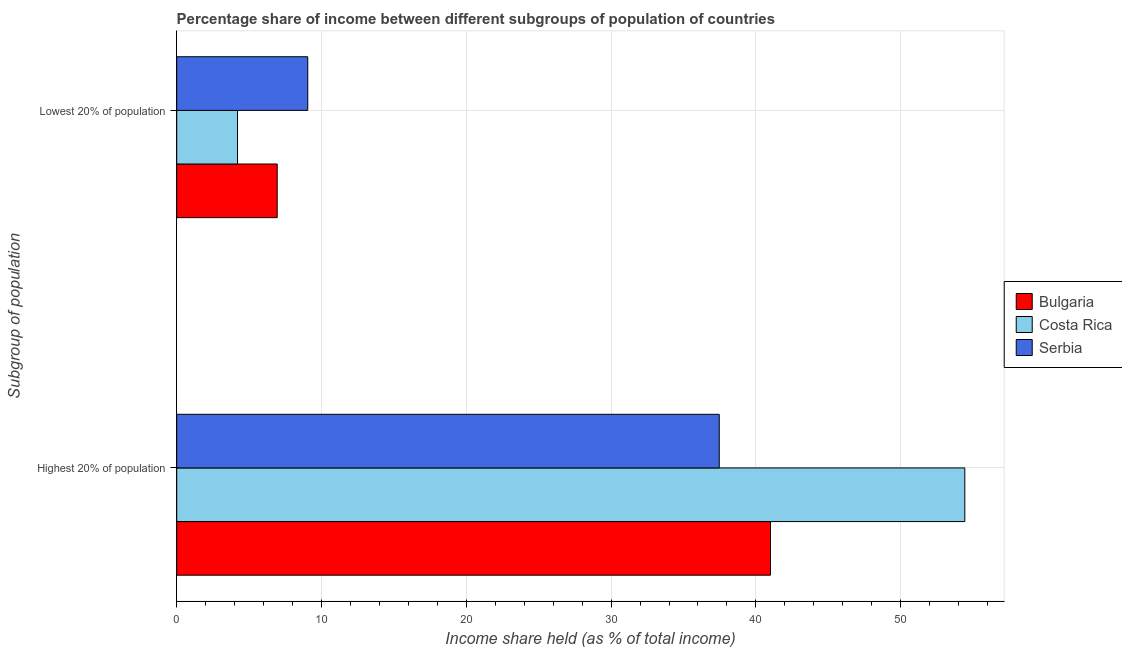Are the number of bars per tick equal to the number of legend labels?
Provide a succinct answer. Yes. How many bars are there on the 2nd tick from the top?
Ensure brevity in your answer.  3. What is the label of the 2nd group of bars from the top?
Offer a terse response. Highest 20% of population. What is the income share held by highest 20% of the population in Costa Rica?
Your answer should be very brief. 54.43. Across all countries, what is the maximum income share held by highest 20% of the population?
Offer a terse response. 54.43. In which country was the income share held by lowest 20% of the population maximum?
Make the answer very short. Serbia. In which country was the income share held by highest 20% of the population minimum?
Your answer should be very brief. Serbia. What is the total income share held by lowest 20% of the population in the graph?
Ensure brevity in your answer.  20.19. What is the difference between the income share held by highest 20% of the population in Serbia and that in Bulgaria?
Your answer should be very brief. -3.54. What is the difference between the income share held by highest 20% of the population in Bulgaria and the income share held by lowest 20% of the population in Costa Rica?
Provide a succinct answer. 36.81. What is the average income share held by lowest 20% of the population per country?
Your response must be concise. 6.73. What is the difference between the income share held by highest 20% of the population and income share held by lowest 20% of the population in Bulgaria?
Your response must be concise. 34.07. In how many countries, is the income share held by highest 20% of the population greater than 6 %?
Keep it short and to the point. 3. What is the ratio of the income share held by highest 20% of the population in Costa Rica to that in Bulgaria?
Make the answer very short. 1.33. Is the income share held by highest 20% of the population in Serbia less than that in Costa Rica?
Your answer should be compact. Yes. In how many countries, is the income share held by lowest 20% of the population greater than the average income share held by lowest 20% of the population taken over all countries?
Offer a terse response. 2. How many bars are there?
Give a very brief answer. 6. How many countries are there in the graph?
Ensure brevity in your answer.  3. Does the graph contain grids?
Make the answer very short. Yes. Where does the legend appear in the graph?
Make the answer very short. Center right. How are the legend labels stacked?
Your response must be concise. Vertical. What is the title of the graph?
Offer a terse response. Percentage share of income between different subgroups of population of countries. What is the label or title of the X-axis?
Make the answer very short. Income share held (as % of total income). What is the label or title of the Y-axis?
Your response must be concise. Subgroup of population. What is the Income share held (as % of total income) in Bulgaria in Highest 20% of population?
Keep it short and to the point. 41.01. What is the Income share held (as % of total income) of Costa Rica in Highest 20% of population?
Ensure brevity in your answer.  54.43. What is the Income share held (as % of total income) of Serbia in Highest 20% of population?
Provide a short and direct response. 37.47. What is the Income share held (as % of total income) in Bulgaria in Lowest 20% of population?
Offer a very short reply. 6.94. What is the Income share held (as % of total income) of Serbia in Lowest 20% of population?
Your answer should be compact. 9.05. Across all Subgroup of population, what is the maximum Income share held (as % of total income) in Bulgaria?
Your answer should be very brief. 41.01. Across all Subgroup of population, what is the maximum Income share held (as % of total income) in Costa Rica?
Your response must be concise. 54.43. Across all Subgroup of population, what is the maximum Income share held (as % of total income) of Serbia?
Your answer should be compact. 37.47. Across all Subgroup of population, what is the minimum Income share held (as % of total income) in Bulgaria?
Provide a succinct answer. 6.94. Across all Subgroup of population, what is the minimum Income share held (as % of total income) in Costa Rica?
Your answer should be compact. 4.2. Across all Subgroup of population, what is the minimum Income share held (as % of total income) in Serbia?
Your answer should be compact. 9.05. What is the total Income share held (as % of total income) of Bulgaria in the graph?
Give a very brief answer. 47.95. What is the total Income share held (as % of total income) of Costa Rica in the graph?
Your response must be concise. 58.63. What is the total Income share held (as % of total income) in Serbia in the graph?
Offer a terse response. 46.52. What is the difference between the Income share held (as % of total income) in Bulgaria in Highest 20% of population and that in Lowest 20% of population?
Ensure brevity in your answer.  34.07. What is the difference between the Income share held (as % of total income) in Costa Rica in Highest 20% of population and that in Lowest 20% of population?
Offer a terse response. 50.23. What is the difference between the Income share held (as % of total income) in Serbia in Highest 20% of population and that in Lowest 20% of population?
Offer a very short reply. 28.42. What is the difference between the Income share held (as % of total income) in Bulgaria in Highest 20% of population and the Income share held (as % of total income) in Costa Rica in Lowest 20% of population?
Provide a short and direct response. 36.81. What is the difference between the Income share held (as % of total income) in Bulgaria in Highest 20% of population and the Income share held (as % of total income) in Serbia in Lowest 20% of population?
Your answer should be very brief. 31.96. What is the difference between the Income share held (as % of total income) in Costa Rica in Highest 20% of population and the Income share held (as % of total income) in Serbia in Lowest 20% of population?
Give a very brief answer. 45.38. What is the average Income share held (as % of total income) of Bulgaria per Subgroup of population?
Keep it short and to the point. 23.98. What is the average Income share held (as % of total income) of Costa Rica per Subgroup of population?
Your answer should be compact. 29.32. What is the average Income share held (as % of total income) in Serbia per Subgroup of population?
Give a very brief answer. 23.26. What is the difference between the Income share held (as % of total income) of Bulgaria and Income share held (as % of total income) of Costa Rica in Highest 20% of population?
Your answer should be compact. -13.42. What is the difference between the Income share held (as % of total income) of Bulgaria and Income share held (as % of total income) of Serbia in Highest 20% of population?
Give a very brief answer. 3.54. What is the difference between the Income share held (as % of total income) of Costa Rica and Income share held (as % of total income) of Serbia in Highest 20% of population?
Give a very brief answer. 16.96. What is the difference between the Income share held (as % of total income) of Bulgaria and Income share held (as % of total income) of Costa Rica in Lowest 20% of population?
Make the answer very short. 2.74. What is the difference between the Income share held (as % of total income) in Bulgaria and Income share held (as % of total income) in Serbia in Lowest 20% of population?
Provide a succinct answer. -2.11. What is the difference between the Income share held (as % of total income) in Costa Rica and Income share held (as % of total income) in Serbia in Lowest 20% of population?
Ensure brevity in your answer.  -4.85. What is the ratio of the Income share held (as % of total income) in Bulgaria in Highest 20% of population to that in Lowest 20% of population?
Ensure brevity in your answer.  5.91. What is the ratio of the Income share held (as % of total income) in Costa Rica in Highest 20% of population to that in Lowest 20% of population?
Make the answer very short. 12.96. What is the ratio of the Income share held (as % of total income) of Serbia in Highest 20% of population to that in Lowest 20% of population?
Keep it short and to the point. 4.14. What is the difference between the highest and the second highest Income share held (as % of total income) of Bulgaria?
Your answer should be very brief. 34.07. What is the difference between the highest and the second highest Income share held (as % of total income) in Costa Rica?
Your answer should be very brief. 50.23. What is the difference between the highest and the second highest Income share held (as % of total income) in Serbia?
Ensure brevity in your answer.  28.42. What is the difference between the highest and the lowest Income share held (as % of total income) in Bulgaria?
Ensure brevity in your answer.  34.07. What is the difference between the highest and the lowest Income share held (as % of total income) of Costa Rica?
Ensure brevity in your answer.  50.23. What is the difference between the highest and the lowest Income share held (as % of total income) in Serbia?
Offer a terse response. 28.42. 